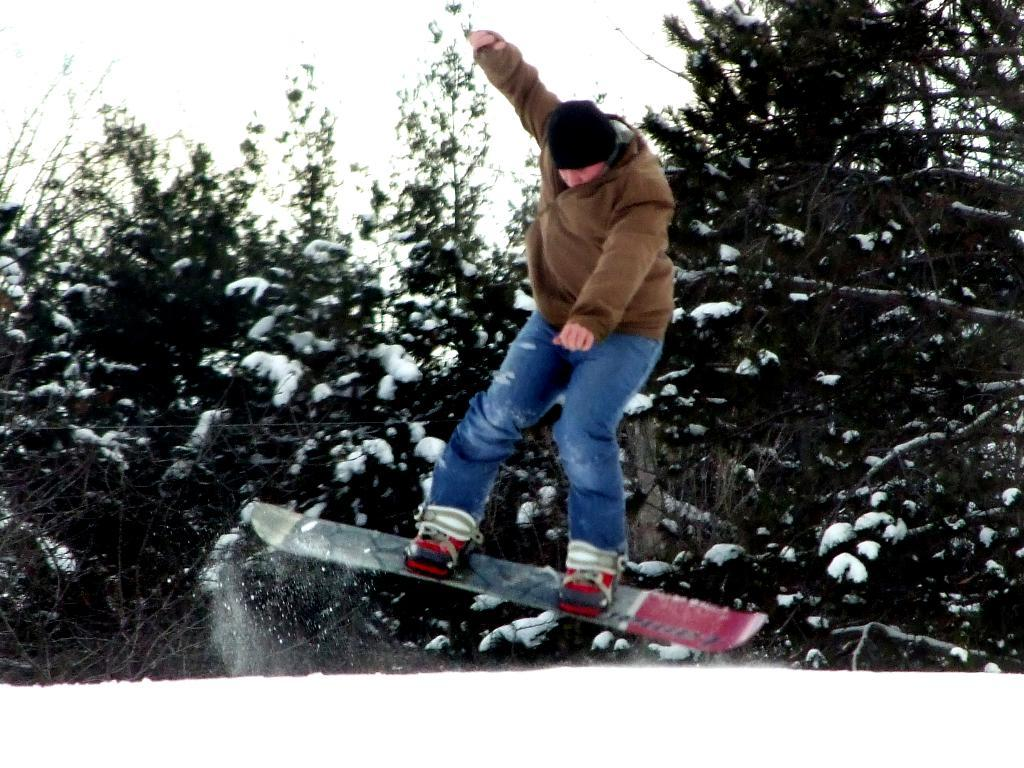What activity is the person in the image engaged in? There is a person snowboarding in the image. What can be seen in the background of the image? There is a group of trees covered with snow in the background. What else is visible in the background of the image? The sky is visible in the background. What type of ray can be seen swimming in the snow in the image? There are no rays present in the image, as it features a person snowboarding and a snow-covered landscape. 